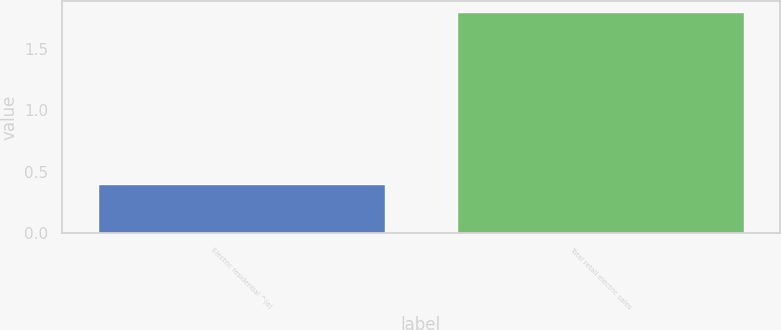<chart> <loc_0><loc_0><loc_500><loc_500><bar_chart><fcel>Electric residential ^(a)<fcel>Total retail electric sales<nl><fcel>0.4<fcel>1.8<nl></chart> 